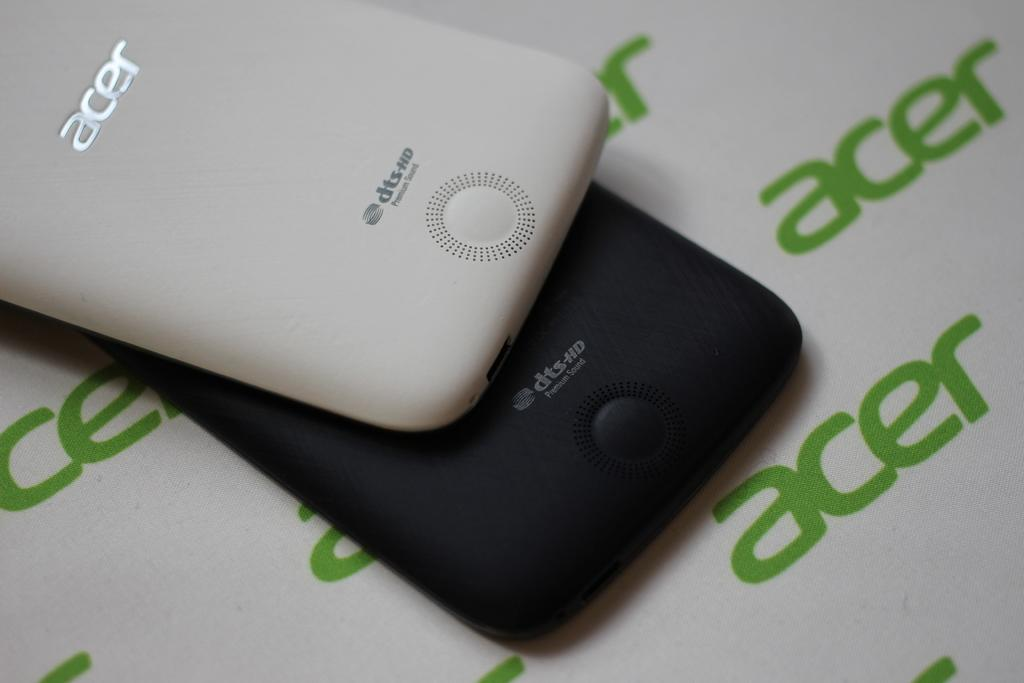<image>
Share a concise interpretation of the image provided. a black and a white cell phone on an acer print background 